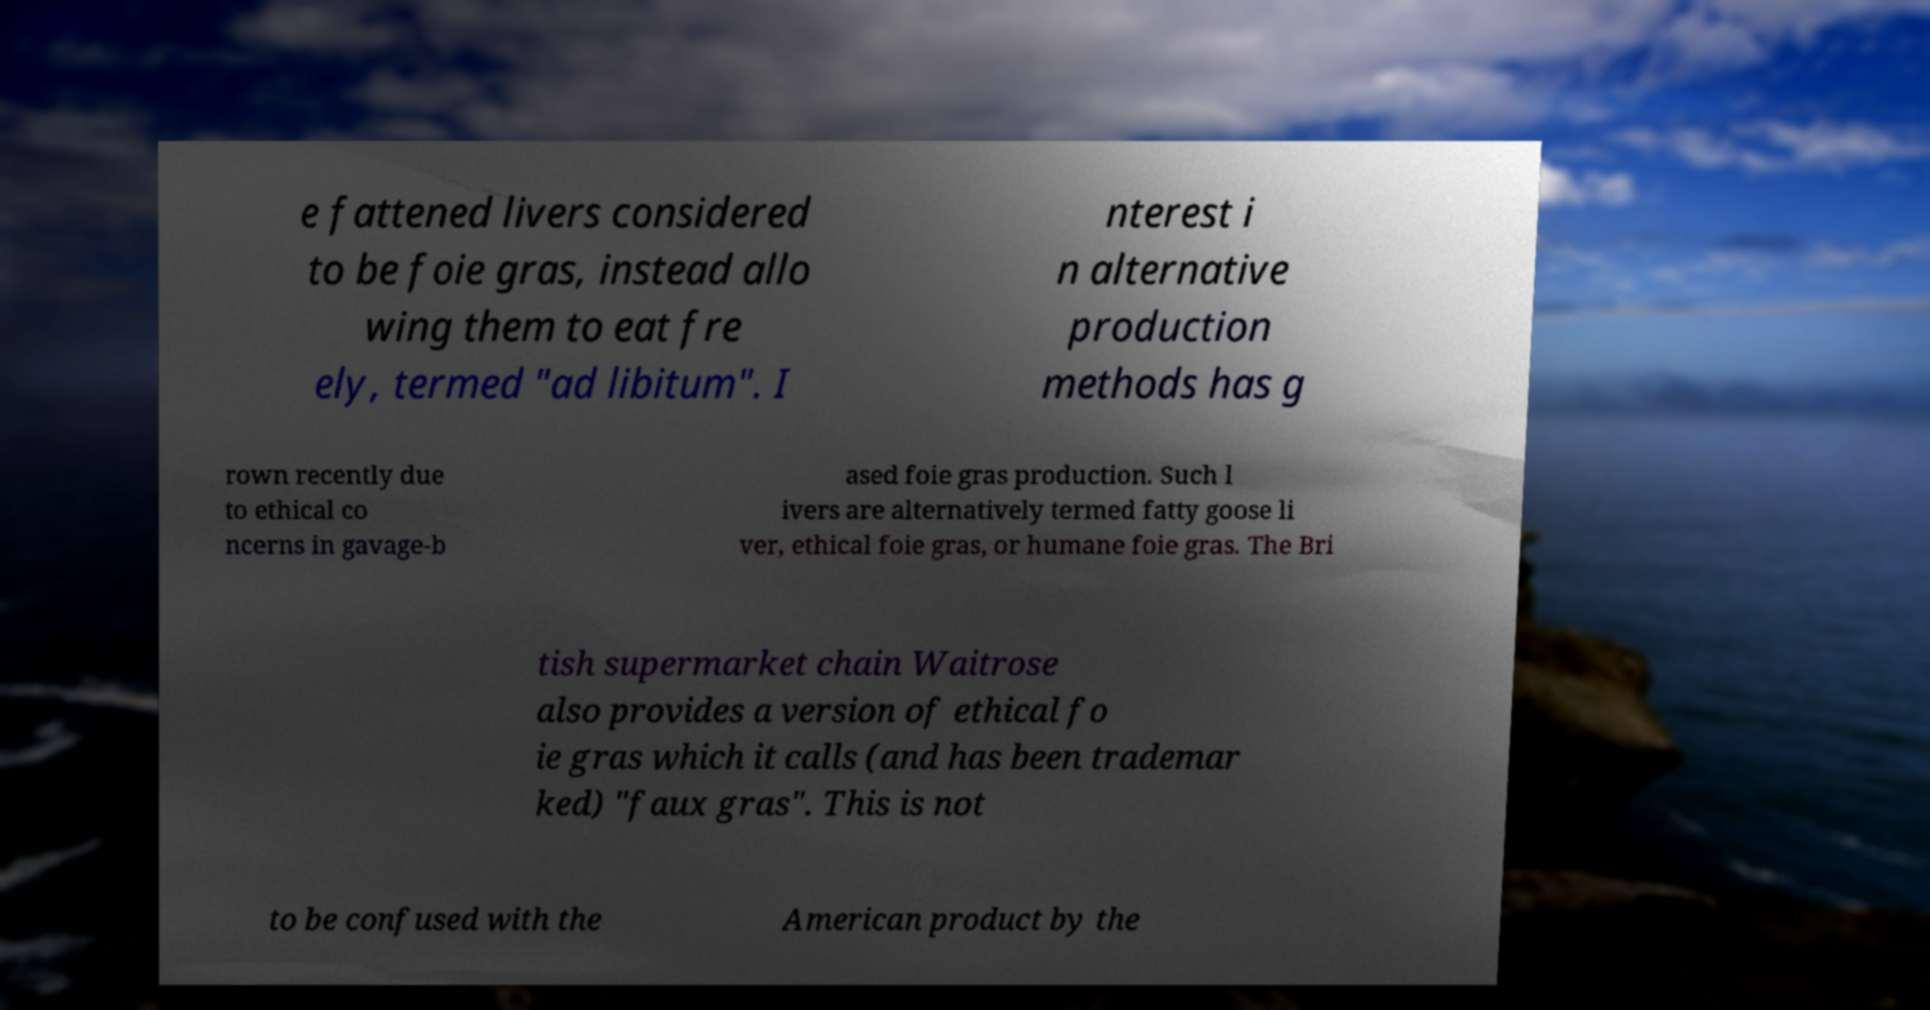What messages or text are displayed in this image? I need them in a readable, typed format. e fattened livers considered to be foie gras, instead allo wing them to eat fre ely, termed "ad libitum". I nterest i n alternative production methods has g rown recently due to ethical co ncerns in gavage-b ased foie gras production. Such l ivers are alternatively termed fatty goose li ver, ethical foie gras, or humane foie gras. The Bri tish supermarket chain Waitrose also provides a version of ethical fo ie gras which it calls (and has been trademar ked) "faux gras". This is not to be confused with the American product by the 